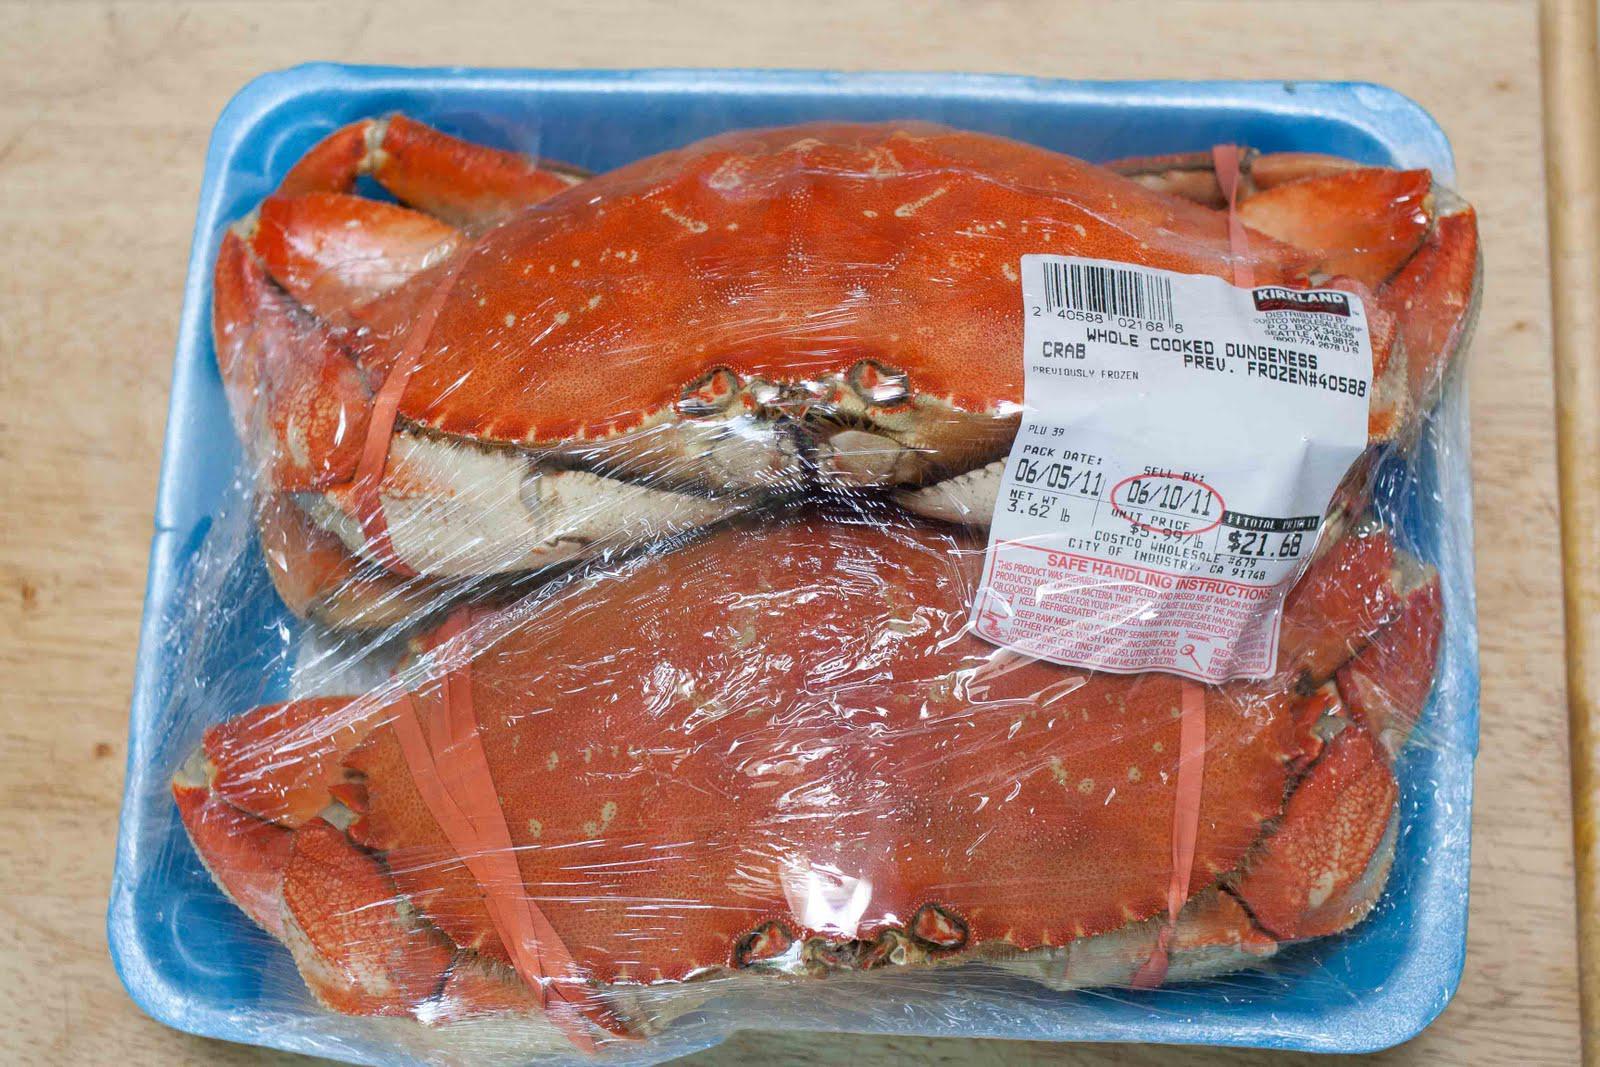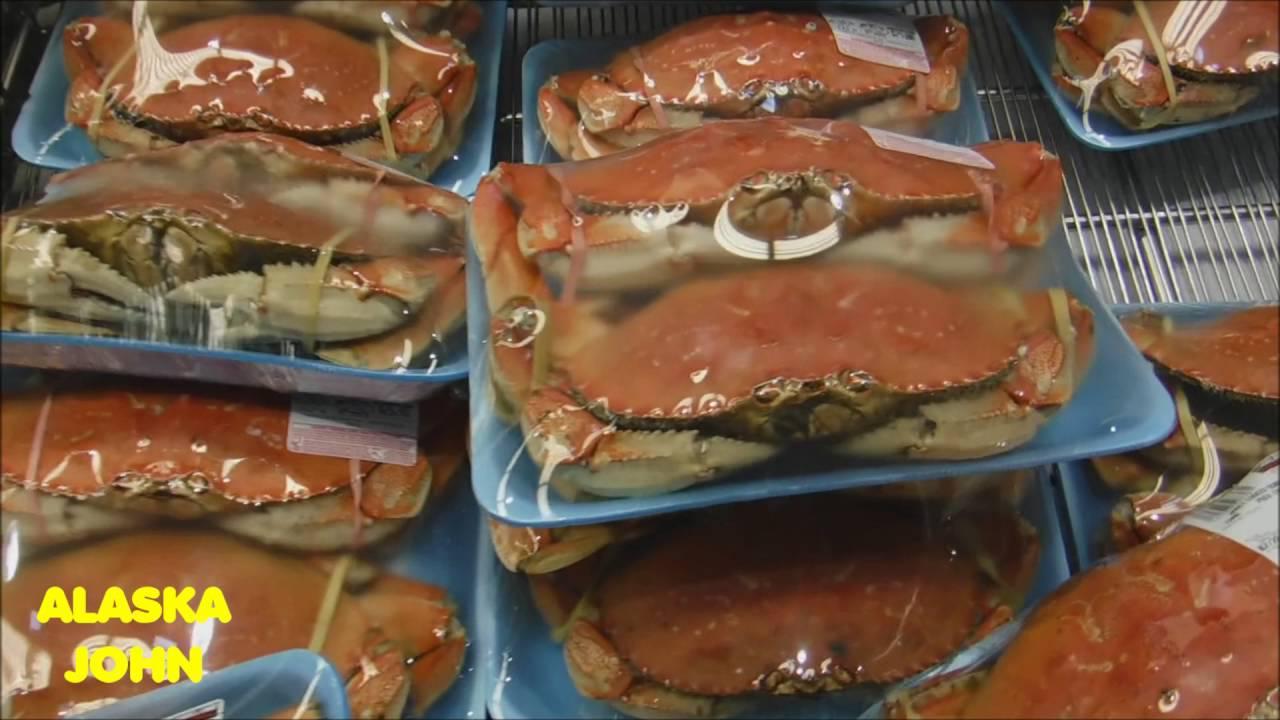The first image is the image on the left, the second image is the image on the right. Assess this claim about the two images: "There is a single package of two crabs in an image.". Correct or not? Answer yes or no. Yes. The first image is the image on the left, the second image is the image on the right. Assess this claim about the two images: "In at least one image there is a total two crabs wrap in a single blue and plastic container.". Correct or not? Answer yes or no. Yes. 